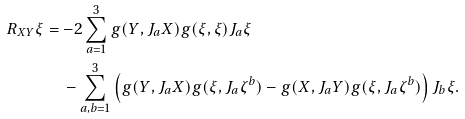Convert formula to latex. <formula><loc_0><loc_0><loc_500><loc_500>R _ { X Y } \xi & = - 2 \sum _ { a = 1 } ^ { 3 } g ( Y , J _ { a } X ) g ( \xi , \xi ) J _ { a } \xi \\ & \quad - \sum _ { a , b = 1 } ^ { 3 } \left ( g ( Y , J _ { a } X ) g ( \xi , J _ { a } \zeta ^ { b } ) - g ( X , J _ { a } Y ) g ( \xi , J _ { a } \zeta ^ { b } ) \right ) J _ { b } \xi .</formula> 